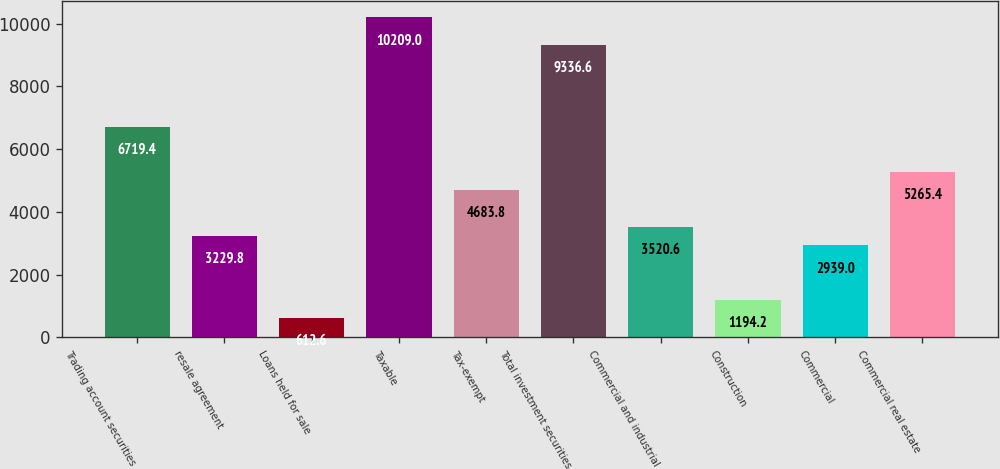Convert chart to OTSL. <chart><loc_0><loc_0><loc_500><loc_500><bar_chart><fcel>Trading account securities<fcel>resale agreement<fcel>Loans held for sale<fcel>Taxable<fcel>Tax-exempt<fcel>Total investment securities<fcel>Commercial and industrial<fcel>Construction<fcel>Commercial<fcel>Commercial real estate<nl><fcel>6719.4<fcel>3229.8<fcel>612.6<fcel>10209<fcel>4683.8<fcel>9336.6<fcel>3520.6<fcel>1194.2<fcel>2939<fcel>5265.4<nl></chart> 